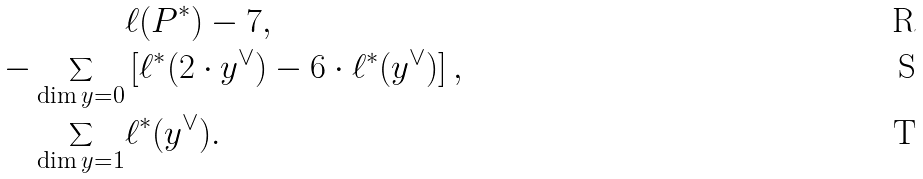Convert formula to latex. <formula><loc_0><loc_0><loc_500><loc_500>& \ell ( P ^ { * } ) - 7 , \\ - \sum _ { \dim y = 0 } & \left [ \ell ^ { * } ( 2 \cdot y ^ { \vee } ) - 6 \cdot \ell ^ { * } ( y ^ { \vee } ) \right ] , \\ \sum _ { \dim y = 1 } & \ell ^ { * } ( y ^ { \vee } ) .</formula> 